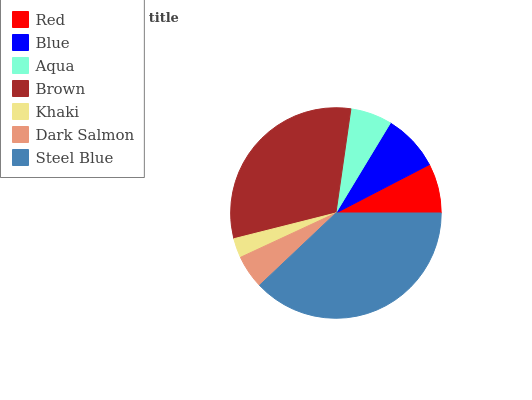Is Khaki the minimum?
Answer yes or no. Yes. Is Steel Blue the maximum?
Answer yes or no. Yes. Is Blue the minimum?
Answer yes or no. No. Is Blue the maximum?
Answer yes or no. No. Is Blue greater than Red?
Answer yes or no. Yes. Is Red less than Blue?
Answer yes or no. Yes. Is Red greater than Blue?
Answer yes or no. No. Is Blue less than Red?
Answer yes or no. No. Is Red the high median?
Answer yes or no. Yes. Is Red the low median?
Answer yes or no. Yes. Is Brown the high median?
Answer yes or no. No. Is Brown the low median?
Answer yes or no. No. 